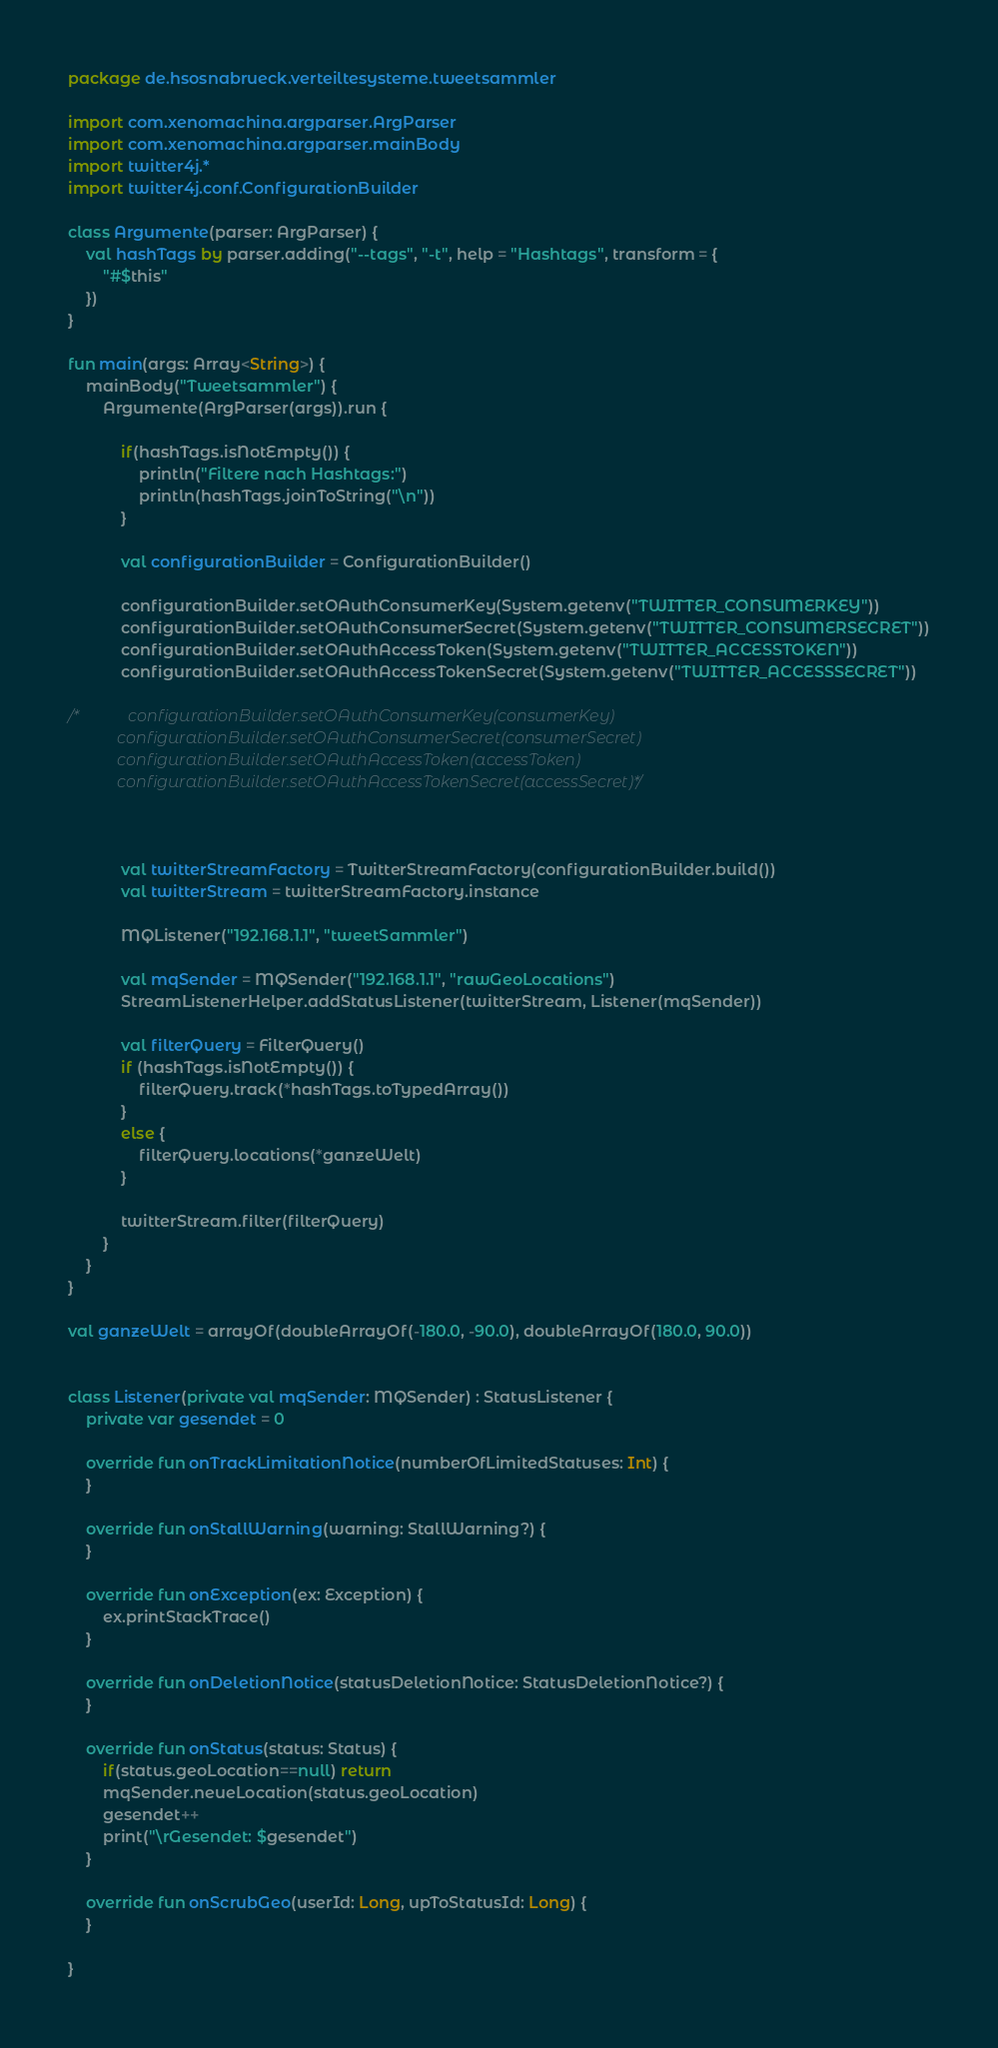Convert code to text. <code><loc_0><loc_0><loc_500><loc_500><_Kotlin_>package de.hsosnabrueck.verteiltesysteme.tweetsammler

import com.xenomachina.argparser.ArgParser
import com.xenomachina.argparser.mainBody
import twitter4j.*
import twitter4j.conf.ConfigurationBuilder

class Argumente(parser: ArgParser) {
    val hashTags by parser.adding("--tags", "-t", help = "Hashtags", transform = {
        "#$this"
    })
}

fun main(args: Array<String>) {
    mainBody("Tweetsammler") {
        Argumente(ArgParser(args)).run {

            if(hashTags.isNotEmpty()) {
                println("Filtere nach Hashtags:")
                println(hashTags.joinToString("\n"))
            }

            val configurationBuilder = ConfigurationBuilder()

            configurationBuilder.setOAuthConsumerKey(System.getenv("TWITTER_CONSUMERKEY"))
            configurationBuilder.setOAuthConsumerSecret(System.getenv("TWITTER_CONSUMERSECRET"))
            configurationBuilder.setOAuthAccessToken(System.getenv("TWITTER_ACCESSTOKEN"))
            configurationBuilder.setOAuthAccessTokenSecret(System.getenv("TWITTER_ACCESSSECRET"))

/*            configurationBuilder.setOAuthConsumerKey(consumerKey)
            configurationBuilder.setOAuthConsumerSecret(consumerSecret)
            configurationBuilder.setOAuthAccessToken(accessToken)
            configurationBuilder.setOAuthAccessTokenSecret(accessSecret)*/



            val twitterStreamFactory = TwitterStreamFactory(configurationBuilder.build())
            val twitterStream = twitterStreamFactory.instance

            MQListener("192.168.1.1", "tweetSammler")

            val mqSender = MQSender("192.168.1.1", "rawGeoLocations")
            StreamListenerHelper.addStatusListener(twitterStream, Listener(mqSender))

            val filterQuery = FilterQuery()
            if (hashTags.isNotEmpty()) {
                filterQuery.track(*hashTags.toTypedArray())
            }
            else {
                filterQuery.locations(*ganzeWelt)
            }

            twitterStream.filter(filterQuery)
        }
    }
}

val ganzeWelt = arrayOf(doubleArrayOf(-180.0, -90.0), doubleArrayOf(180.0, 90.0))


class Listener(private val mqSender: MQSender) : StatusListener {
    private var gesendet = 0

    override fun onTrackLimitationNotice(numberOfLimitedStatuses: Int) {
    }

    override fun onStallWarning(warning: StallWarning?) {
    }

    override fun onException(ex: Exception) {
        ex.printStackTrace()
    }

    override fun onDeletionNotice(statusDeletionNotice: StatusDeletionNotice?) {
    }

    override fun onStatus(status: Status) {
        if(status.geoLocation==null) return
        mqSender.neueLocation(status.geoLocation)
        gesendet++
        print("\rGesendet: $gesendet")
    }

    override fun onScrubGeo(userId: Long, upToStatusId: Long) {
    }

}

</code> 